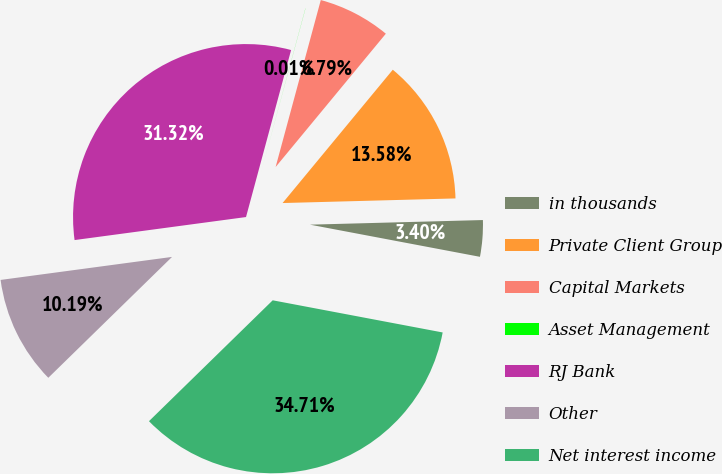Convert chart. <chart><loc_0><loc_0><loc_500><loc_500><pie_chart><fcel>in thousands<fcel>Private Client Group<fcel>Capital Markets<fcel>Asset Management<fcel>RJ Bank<fcel>Other<fcel>Net interest income<nl><fcel>3.4%<fcel>13.58%<fcel>6.79%<fcel>0.01%<fcel>31.32%<fcel>10.19%<fcel>34.71%<nl></chart> 